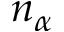<formula> <loc_0><loc_0><loc_500><loc_500>n _ { \alpha }</formula> 